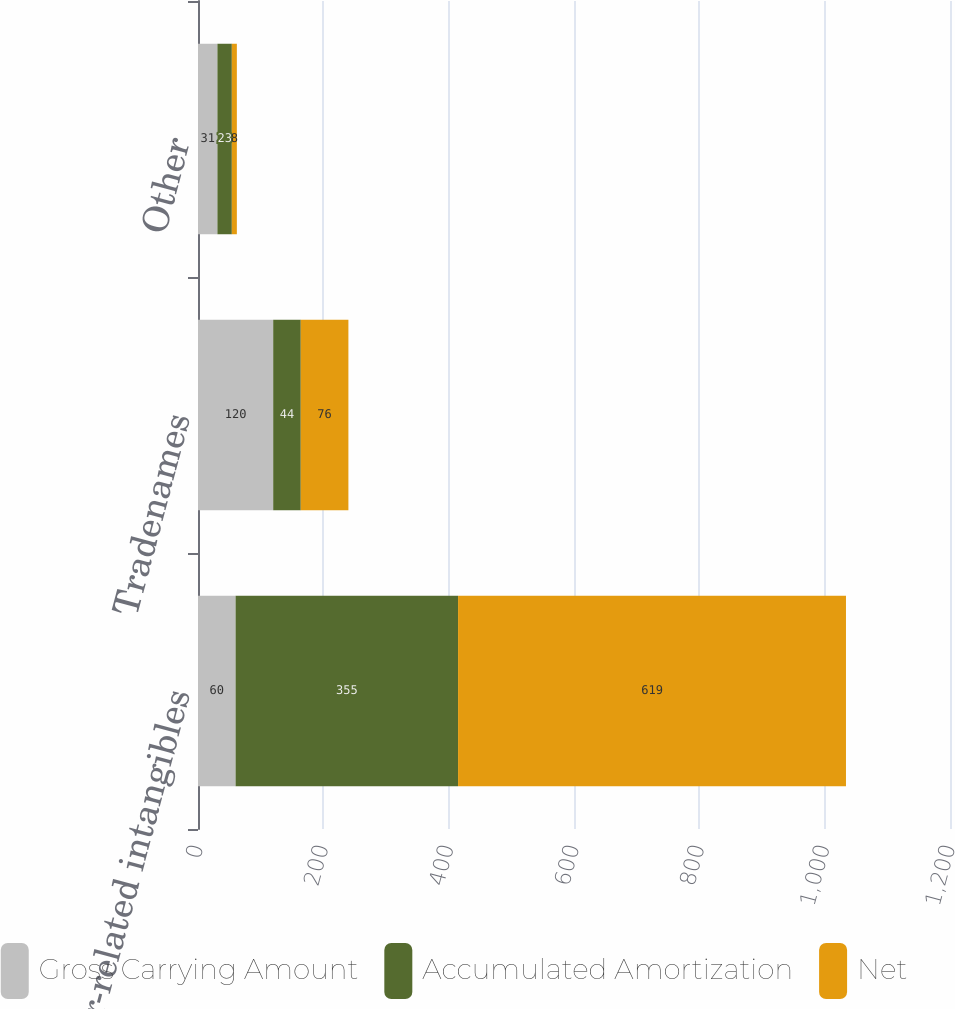Convert chart to OTSL. <chart><loc_0><loc_0><loc_500><loc_500><stacked_bar_chart><ecel><fcel>Customer-related intangibles<fcel>Tradenames<fcel>Other<nl><fcel>Gross Carrying Amount<fcel>60<fcel>120<fcel>31<nl><fcel>Accumulated Amortization<fcel>355<fcel>44<fcel>23<nl><fcel>Net<fcel>619<fcel>76<fcel>8<nl></chart> 